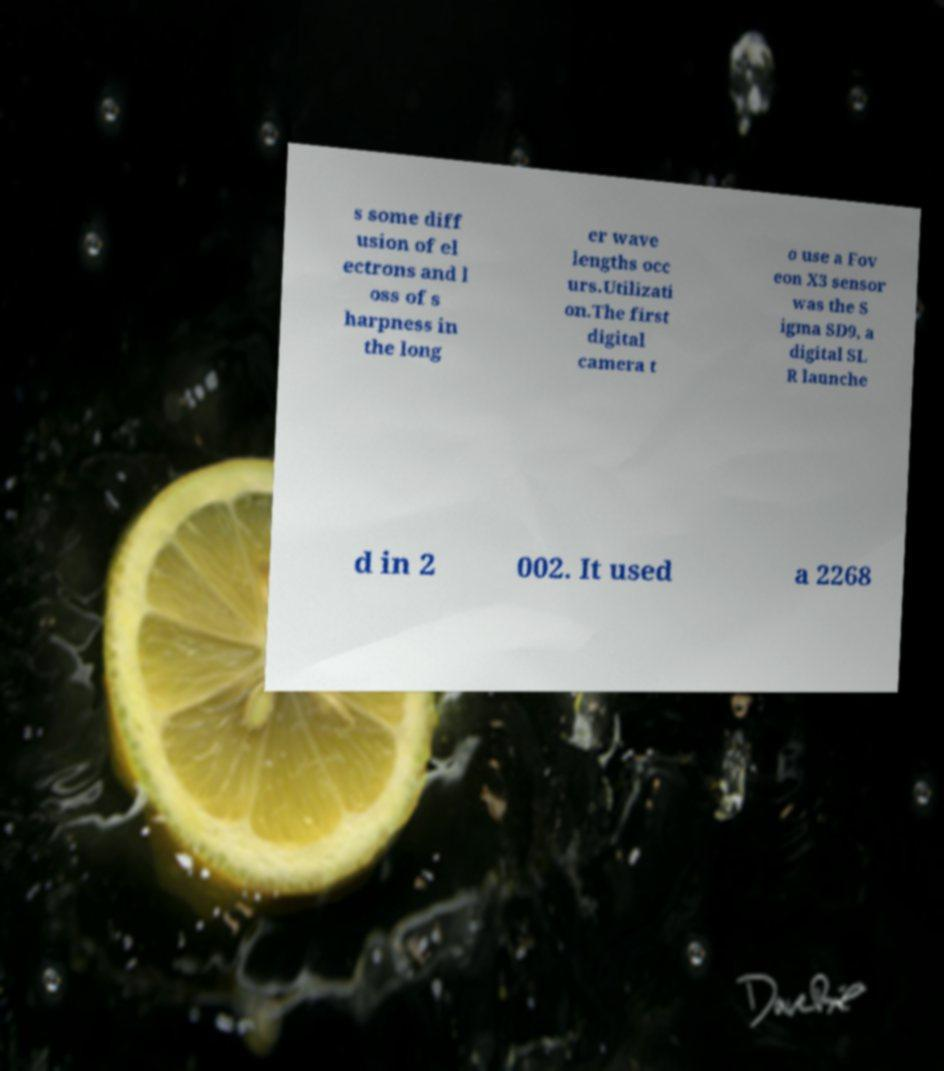Please identify and transcribe the text found in this image. s some diff usion of el ectrons and l oss of s harpness in the long er wave lengths occ urs.Utilizati on.The first digital camera t o use a Fov eon X3 sensor was the S igma SD9, a digital SL R launche d in 2 002. It used a 2268 